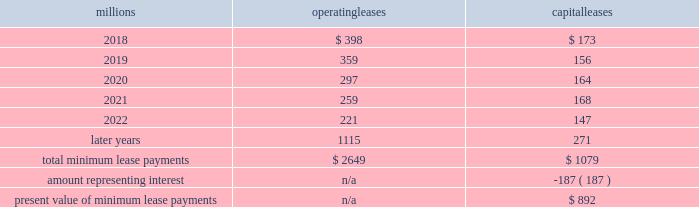17 .
Leases we lease certain locomotives , freight cars , and other property .
The consolidated statements of financial position as of december 31 , 2017 , and 2016 included $ 1635 million , net of $ 953 million of accumulated depreciation , and $ 1997 million , net of $ 1121 million of accumulated depreciation , respectively , for properties held under capital leases .
A charge to income resulting from the depreciation for assets held under capital leases is included within depreciation expense in our consolidated statements of income .
Future minimum lease payments for operating and capital leases with initial or remaining non-cancelable lease terms in excess of one year as of december 31 , 2017 , were as follows : millions operating leases capital leases .
Approximately 97% ( 97 % ) of capital lease payments relate to locomotives .
Rent expense for operating leases with terms exceeding one month was $ 480 million in 2017 , $ 535 million in 2016 , and $ 590 million in 2015 .
When cash rental payments are not made on a straight-line basis , we recognize variable rental expense on a straight-line basis over the lease term .
Contingent rentals and sub-rentals are not significant .
18 .
Commitments and contingencies asserted and unasserted claims 2013 various claims and lawsuits are pending against us and certain of our subsidiaries .
We cannot fully determine the effect of all asserted and unasserted claims on our consolidated results of operations , financial condition , or liquidity .
To the extent possible , we have recorded a liability where asserted and unasserted claims are considered probable and where such claims can be reasonably estimated .
We do not expect that any known lawsuits , claims , environmental costs , commitments , contingent liabilities , or guarantees will have a material adverse effect on our consolidated results of operations , financial condition , or liquidity after taking into account liabilities and insurance recoveries previously recorded for these matters .
Personal injury 2013 the cost of personal injuries to employees and others related to our activities is charged to expense based on estimates of the ultimate cost and number of incidents each year .
We use an actuarial analysis to measure the expense and liability , including unasserted claims .
The federal employers 2019 liability act ( fela ) governs compensation for work-related accidents .
Under fela , damages are assessed based on a finding of fault through litigation or out-of-court settlements .
We offer a comprehensive variety of services and rehabilitation programs for employees who are injured at work .
Our personal injury liability is not discounted to present value due to the uncertainty surrounding the timing of future payments .
Approximately 95% ( 95 % ) of the recorded liability is related to asserted claims and approximately 5% ( 5 % ) is related to unasserted claims at december 31 , 2017 .
Because of the uncertainty surrounding the ultimate outcome of personal injury claims , it is reasonably possible that future costs to settle these claims may range from approximately $ 285 million to $ 310 million .
We record an accrual at the low end of the range as no amount of loss within the range is more probable than any other .
Estimates can vary over time due to evolving trends in litigation. .
What was the ratio of the net properties held under capital leases in 2017 to 2016\\n? 
Computations: (1635 / 1997)
Answer: 0.81873. 